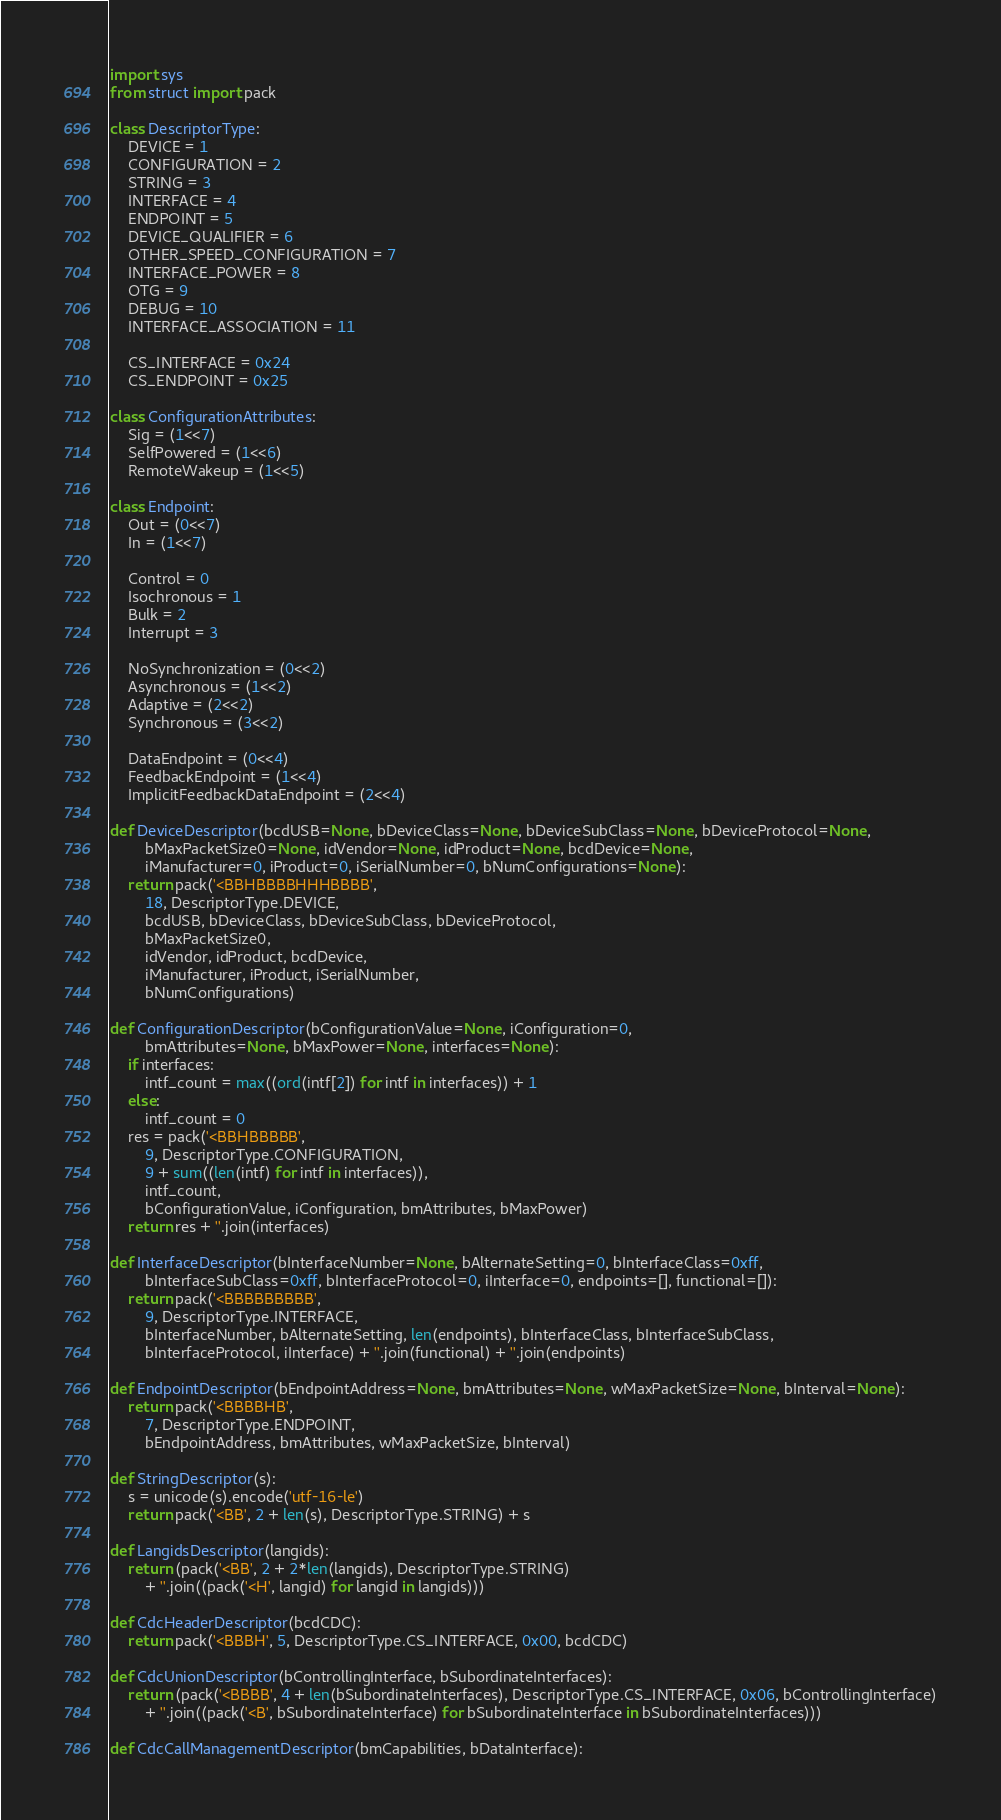Convert code to text. <code><loc_0><loc_0><loc_500><loc_500><_Python_>import sys
from struct import pack

class DescriptorType:
    DEVICE = 1
    CONFIGURATION = 2
    STRING = 3
    INTERFACE = 4
    ENDPOINT = 5
    DEVICE_QUALIFIER = 6
    OTHER_SPEED_CONFIGURATION = 7
    INTERFACE_POWER = 8
    OTG = 9
    DEBUG = 10
    INTERFACE_ASSOCIATION = 11

    CS_INTERFACE = 0x24
    CS_ENDPOINT = 0x25

class ConfigurationAttributes:
    Sig = (1<<7)
    SelfPowered = (1<<6)
    RemoteWakeup = (1<<5)

class Endpoint:
    Out = (0<<7)
    In = (1<<7)

    Control = 0
    Isochronous = 1
    Bulk = 2
    Interrupt = 3

    NoSynchronization = (0<<2)
    Asynchronous = (1<<2)
    Adaptive = (2<<2)
    Synchronous = (3<<2)

    DataEndpoint = (0<<4)
    FeedbackEndpoint = (1<<4)
    ImplicitFeedbackDataEndpoint = (2<<4)

def DeviceDescriptor(bcdUSB=None, bDeviceClass=None, bDeviceSubClass=None, bDeviceProtocol=None,
        bMaxPacketSize0=None, idVendor=None, idProduct=None, bcdDevice=None,
        iManufacturer=0, iProduct=0, iSerialNumber=0, bNumConfigurations=None):
    return pack('<BBHBBBBHHHBBBB',
        18, DescriptorType.DEVICE,
        bcdUSB, bDeviceClass, bDeviceSubClass, bDeviceProtocol,
        bMaxPacketSize0,
        idVendor, idProduct, bcdDevice,
        iManufacturer, iProduct, iSerialNumber,
        bNumConfigurations)

def ConfigurationDescriptor(bConfigurationValue=None, iConfiguration=0,
        bmAttributes=None, bMaxPower=None, interfaces=None):
    if interfaces:
        intf_count = max((ord(intf[2]) for intf in interfaces)) + 1
    else:
        intf_count = 0
    res = pack('<BBHBBBBB',
        9, DescriptorType.CONFIGURATION,
        9 + sum((len(intf) for intf in interfaces)),
        intf_count,
        bConfigurationValue, iConfiguration, bmAttributes, bMaxPower)
    return res + ''.join(interfaces)

def InterfaceDescriptor(bInterfaceNumber=None, bAlternateSetting=0, bInterfaceClass=0xff,
        bInterfaceSubClass=0xff, bInterfaceProtocol=0, iInterface=0, endpoints=[], functional=[]):
    return pack('<BBBBBBBBB',
        9, DescriptorType.INTERFACE,
        bInterfaceNumber, bAlternateSetting, len(endpoints), bInterfaceClass, bInterfaceSubClass,
        bInterfaceProtocol, iInterface) + ''.join(functional) + ''.join(endpoints)

def EndpointDescriptor(bEndpointAddress=None, bmAttributes=None, wMaxPacketSize=None, bInterval=None):
    return pack('<BBBBHB',
        7, DescriptorType.ENDPOINT,
        bEndpointAddress, bmAttributes, wMaxPacketSize, bInterval)

def StringDescriptor(s):
    s = unicode(s).encode('utf-16-le')
    return pack('<BB', 2 + len(s), DescriptorType.STRING) + s

def LangidsDescriptor(langids):
    return (pack('<BB', 2 + 2*len(langids), DescriptorType.STRING)
        + ''.join((pack('<H', langid) for langid in langids)))

def CdcHeaderDescriptor(bcdCDC):
    return pack('<BBBH', 5, DescriptorType.CS_INTERFACE, 0x00, bcdCDC)

def CdcUnionDescriptor(bControllingInterface, bSubordinateInterfaces):
    return (pack('<BBBB', 4 + len(bSubordinateInterfaces), DescriptorType.CS_INTERFACE, 0x06, bControllingInterface)
        + ''.join((pack('<B', bSubordinateInterface) for bSubordinateInterface in bSubordinateInterfaces)))

def CdcCallManagementDescriptor(bmCapabilities, bDataInterface):</code> 